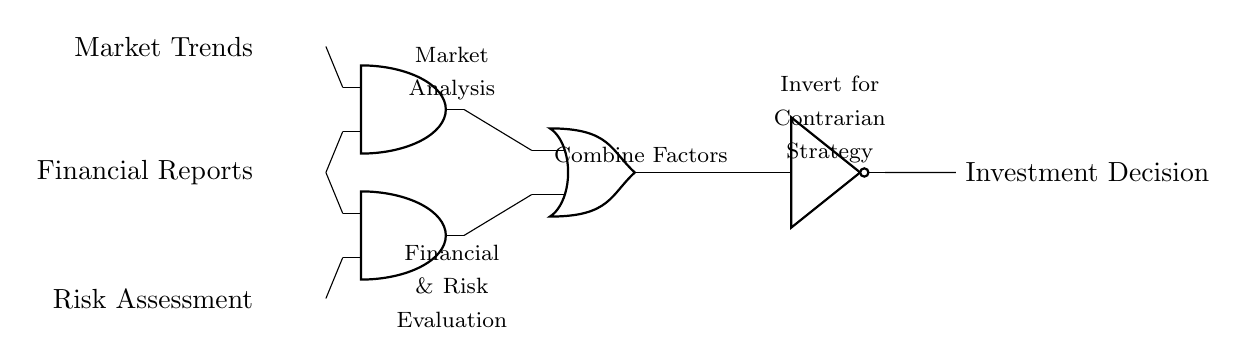What are the input signals in this circuit? The input signals, as indicated on the left side of the diagram, are Market Trends, Financial Reports, and Risk Assessment.
Answer: Market Trends, Financial Reports, Risk Assessment How many AND gates are present in this circuit? There are two AND gates shown in the circuit diagram, labeled as AND1 and AND2, located at coordinates (2,3) and (2,1) respectively.
Answer: 2 What does the OR gate represent in this circuit? The OR gate, labeled Combine Factors, represents the integration of the output signals from both AND gates, determining if either analysis condition results in an investment decision.
Answer: Combine Factors What is the function of the NOT gate in this circuit? The NOT gate is labeled as Invert for Contrarian Strategy and functions to invert the output from the OR gate, indicating a contrarian approach to the investment decision based on combined input evaluations.
Answer: Invert for Contrarian Strategy What is the position of the Financial Reports input relative to the AND gates? The Financial Reports input is connected to both AND gates, appearing at the same vertical level as AND1 and directly above AND2, thus influencing both gates in decision-making.
Answer: Above AND2, at the same level as AND1 What does the output Investment Decision depend on? The output Investment Decision depends on the combined logic from both AND gates through the OR gate, ultimately influenced by the evaluations of market trends, financial reports, and risk assessments processed through these gates.
Answer: Combined logic from AND gates 